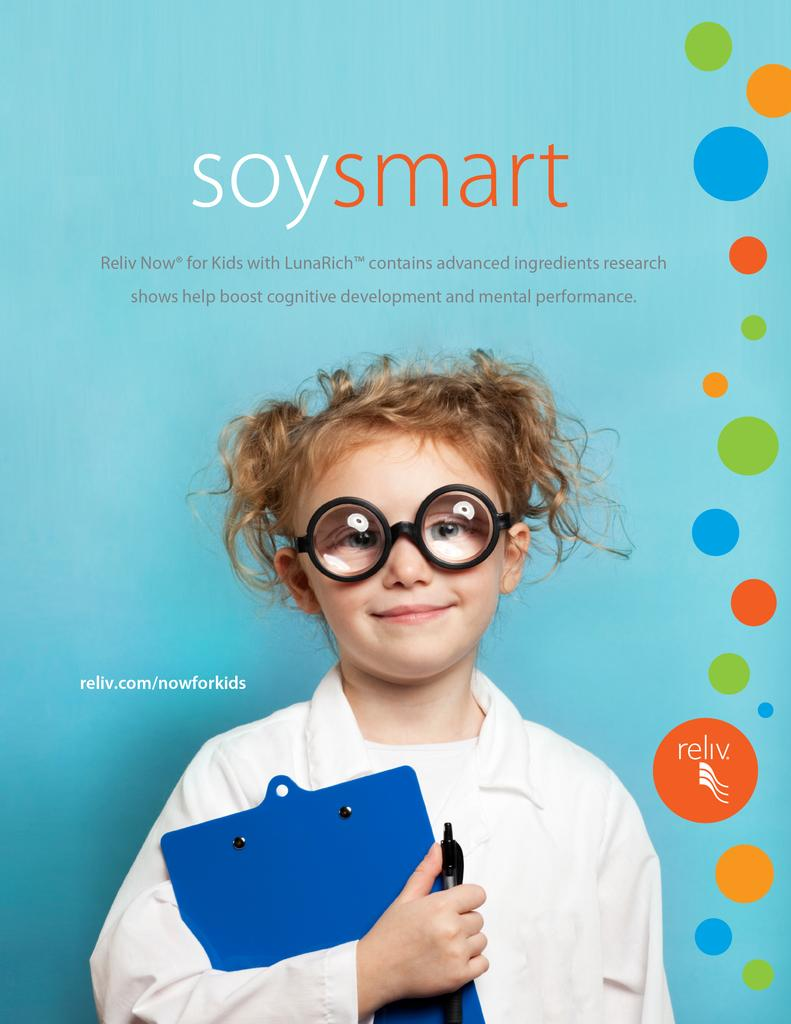What is the main subject of the image? The main subject of the image is a kid. What is the kid doing in the image? The kid is standing in the image. What is the kid holding in the image? The kid is holding a blue color pad in the image. What can be seen in the background of the image? There is a poster in the background of the image. How many men are visible in the image? There are no men visible in the image; it features a kid holding a blue color pad. What type of cabbage is being used as a prop in the image? There is no cabbage present in the image. 